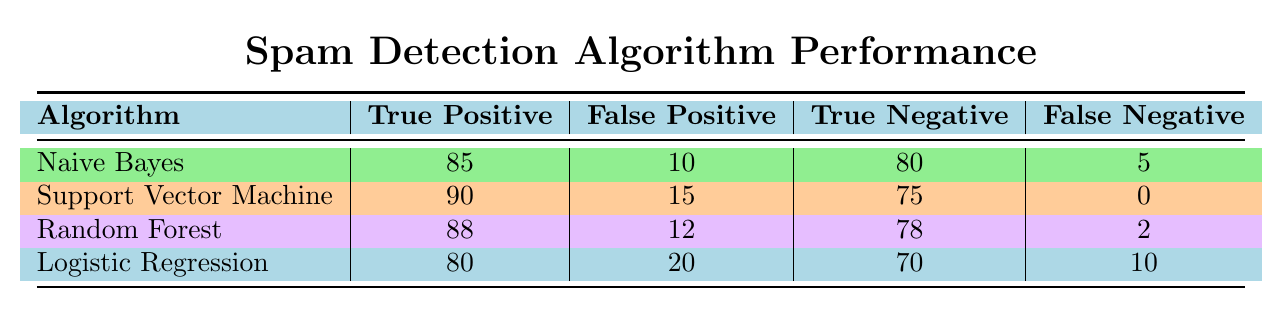What is the true positive rate for the Naive Bayes algorithm? True positive rate is calculated by dividing the true positives by the total actual positives (true positives + false negatives). For Naive Bayes, true positives are 85 and false negatives are 5. Therefore, true positive rate = 85 / (85 + 5) = 85 / 90 = 0.944 or 94.4%.
Answer: 94.4% Which algorithm has the highest number of true negatives? To find the algorithm with the highest number of true negatives, we need to compare the true negative values across all algorithms. True negatives are as follows: Naive Bayes (80), Support Vector Machine (75), Random Forest (78), and Logistic Regression (70). The highest value is 80 for Naive Bayes.
Answer: Naive Bayes Is there any algorithm with zero false negatives? A false negative is when a spam is incorrectly classified as not spam. Looking at the table, Support Vector Machine has zero false negatives, while the others have non-zero values.
Answer: Yes What is the difference between the true positive and false positive rates for Random Forest? True positive rate for Random Forest: true positives (88) / (true positives + false negatives) = 88/90 = 0.978. False positive rate: false positives (12) / (false positives + true negatives) = 12/(12 + 78) = 12/90 = 0.133. The difference is 0.978 - 0.133 = 0.845.
Answer: 0.845 Which algorithm has the most balanced performance between true positives and false positives? To assess balance, we can look at the ratio of true positives to false positives. For each algorithm: Naive Bayes (85/10 = 8.5), Support Vector Machine (90/15 = 6), Random Forest (88/12 = 7.33), Logistic Regression (80/20 = 4). Naive Bayes has the highest ratio of 8.5, indicating the most balanced performance between true positives and false positives.
Answer: Naive Bayes 